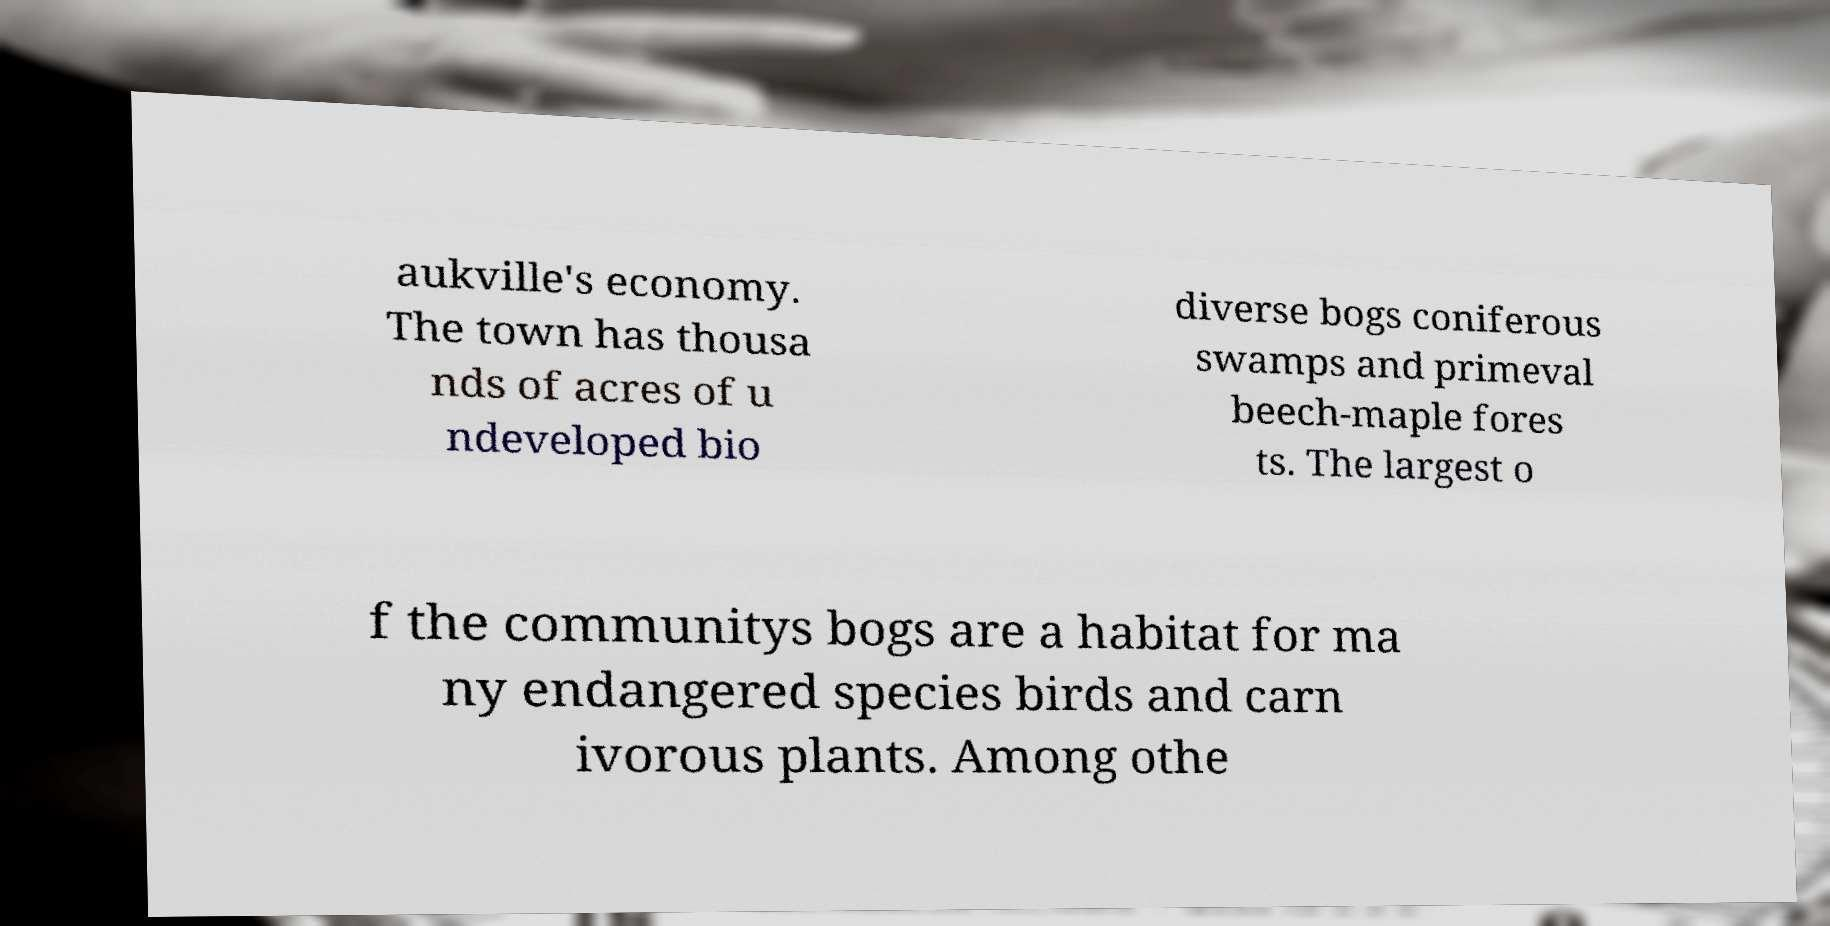There's text embedded in this image that I need extracted. Can you transcribe it verbatim? aukville's economy. The town has thousa nds of acres of u ndeveloped bio diverse bogs coniferous swamps and primeval beech-maple fores ts. The largest o f the communitys bogs are a habitat for ma ny endangered species birds and carn ivorous plants. Among othe 